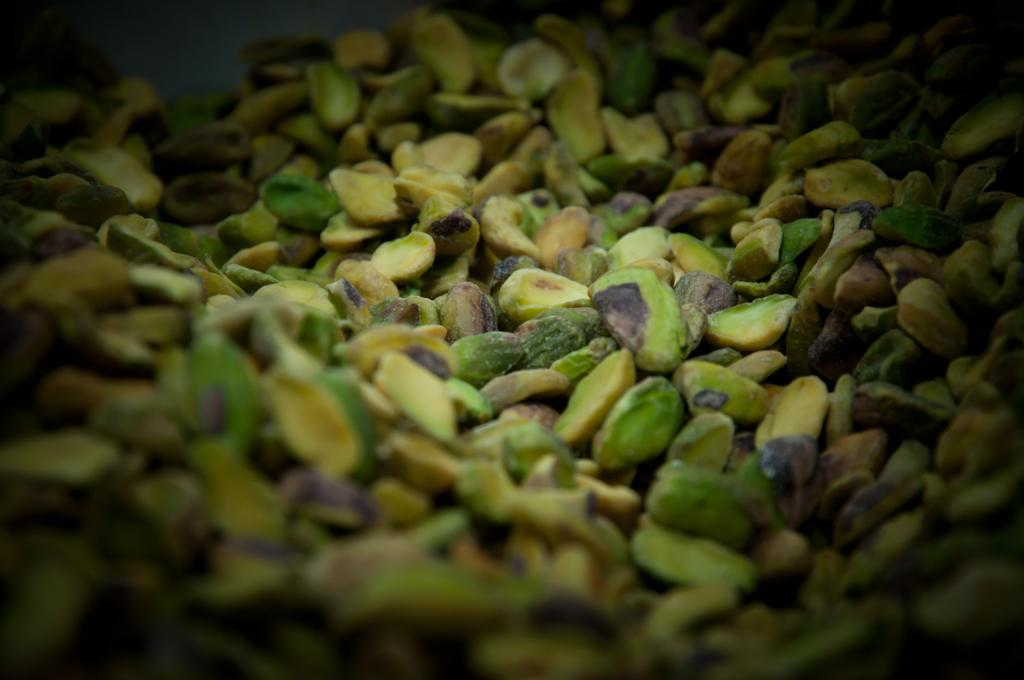What type of food is present in the image? There are pistachios in the image. How many cows are grazing in the field behind the pistachios in the image? There are no cows or fields present in the image; it only features pistachios. 